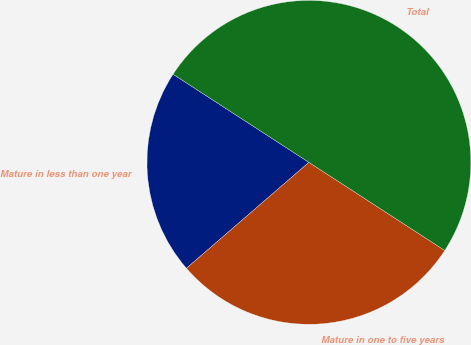Convert chart to OTSL. <chart><loc_0><loc_0><loc_500><loc_500><pie_chart><fcel>Mature in less than one year<fcel>Mature in one to five years<fcel>Total<nl><fcel>20.51%<fcel>29.49%<fcel>50.0%<nl></chart> 